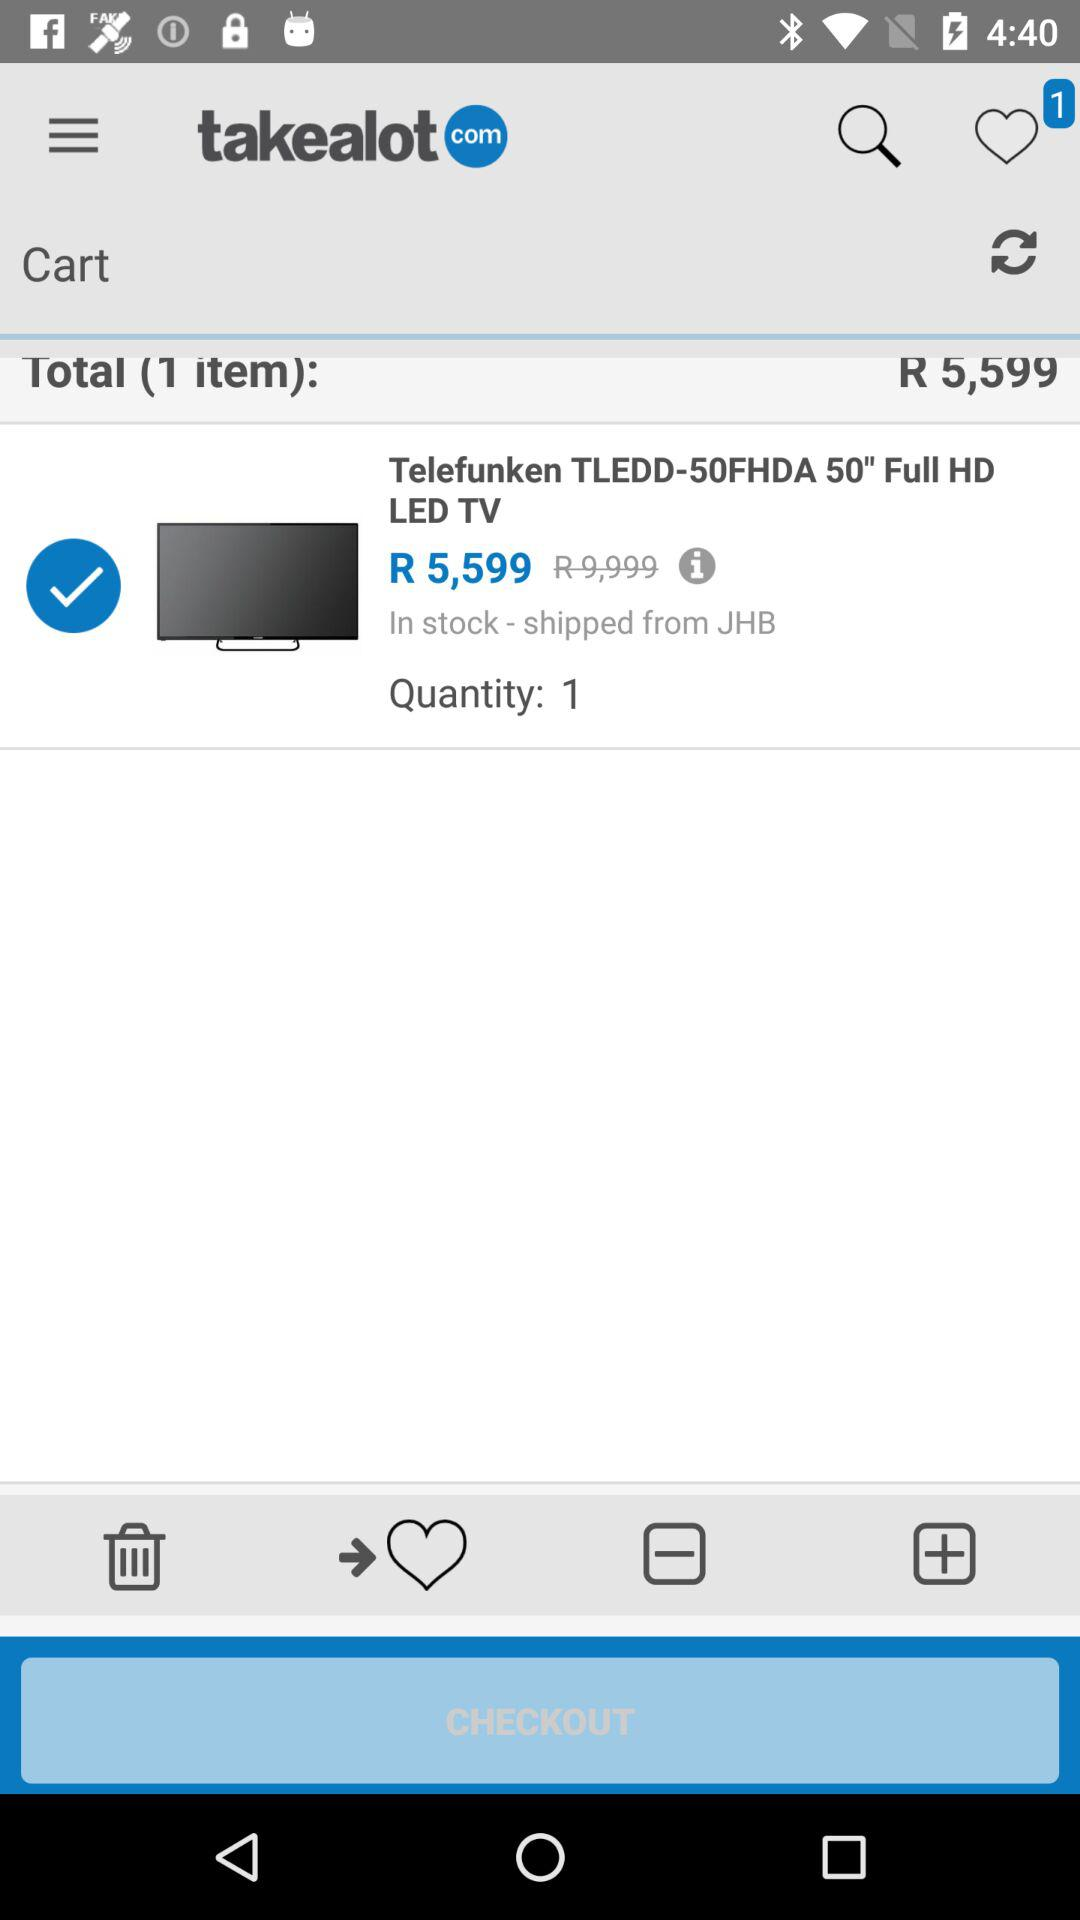How many items in total are there? There is 1 item. 